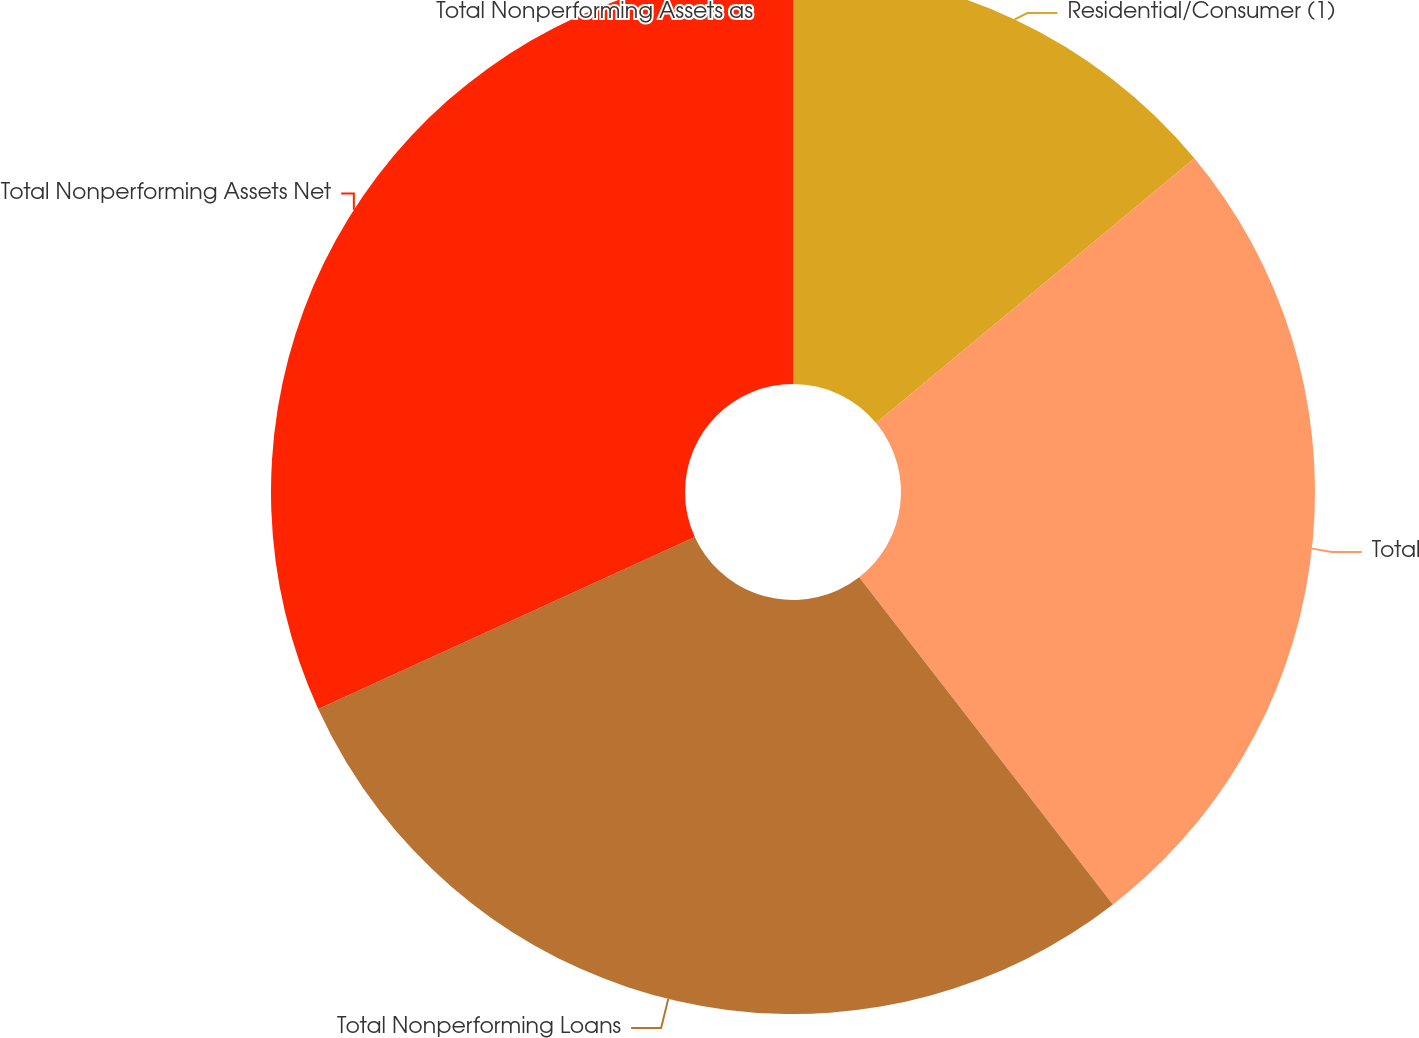<chart> <loc_0><loc_0><loc_500><loc_500><pie_chart><fcel>Residential/Consumer (1)<fcel>Total<fcel>Total Nonperforming Loans<fcel>Total Nonperforming Assets Net<fcel>Total Nonperforming Assets as<nl><fcel>13.96%<fcel>25.54%<fcel>28.68%<fcel>31.82%<fcel>0.0%<nl></chart> 